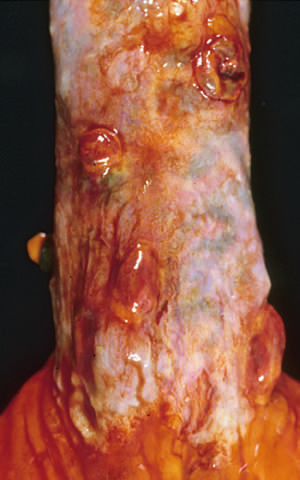what are sites of variceal hemorrhage that were ligated with bands?
Answer the question using a single word or phrase. The polypoid areas 